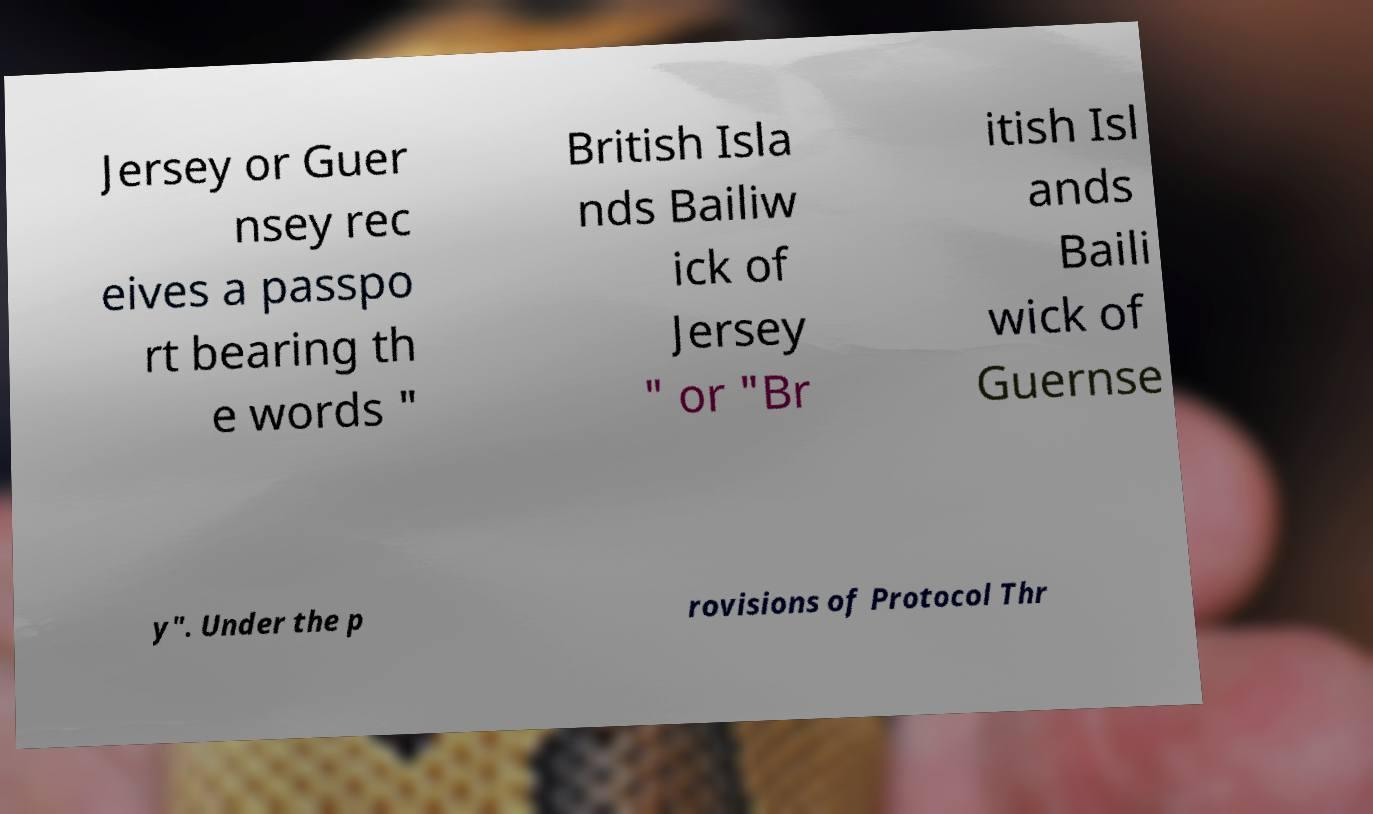I need the written content from this picture converted into text. Can you do that? Jersey or Guer nsey rec eives a passpo rt bearing th e words " British Isla nds Bailiw ick of Jersey " or "Br itish Isl ands Baili wick of Guernse y". Under the p rovisions of Protocol Thr 